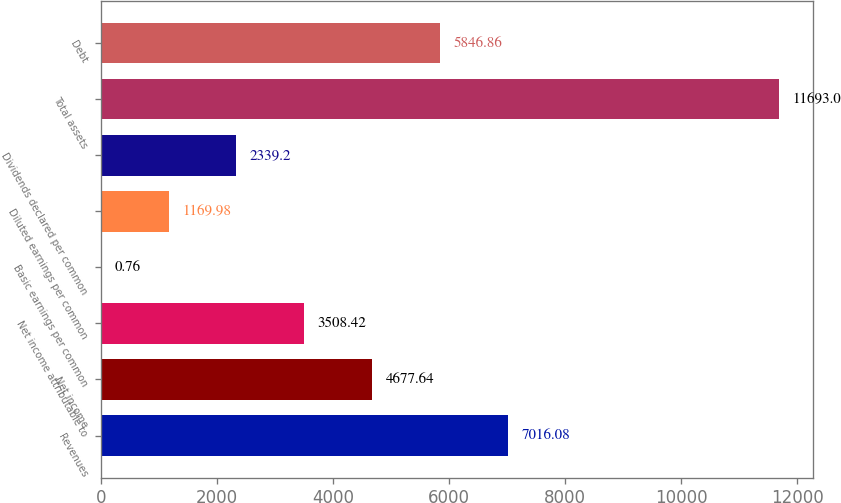<chart> <loc_0><loc_0><loc_500><loc_500><bar_chart><fcel>Revenues<fcel>Net income<fcel>Net income attributable to<fcel>Basic earnings per common<fcel>Diluted earnings per common<fcel>Dividends declared per common<fcel>Total assets<fcel>Debt<nl><fcel>7016.08<fcel>4677.64<fcel>3508.42<fcel>0.76<fcel>1169.98<fcel>2339.2<fcel>11693<fcel>5846.86<nl></chart> 